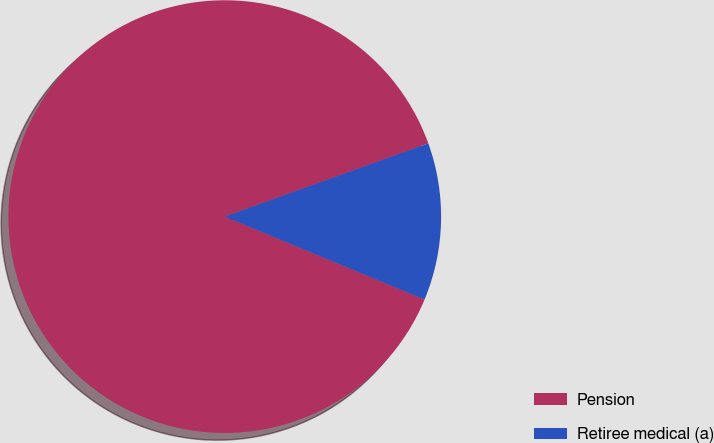<chart> <loc_0><loc_0><loc_500><loc_500><pie_chart><fcel>Pension<fcel>Retiree medical (a)<nl><fcel>88.24%<fcel>11.76%<nl></chart> 